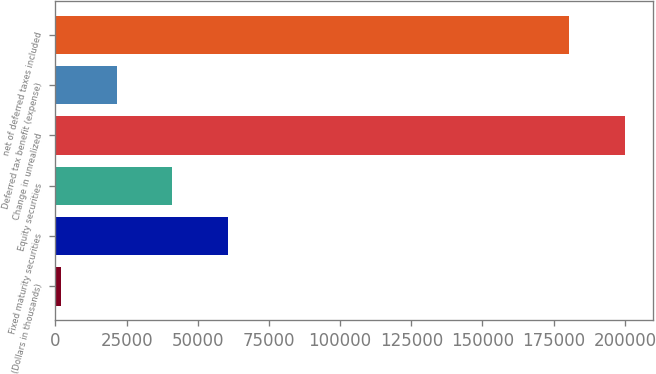Convert chart. <chart><loc_0><loc_0><loc_500><loc_500><bar_chart><fcel>(Dollars in thousands)<fcel>Fixed maturity securities<fcel>Equity securities<fcel>Change in unrealized<fcel>Deferred tax benefit (expense)<fcel>net of deferred taxes included<nl><fcel>2015<fcel>60579.8<fcel>41058.2<fcel>199961<fcel>21536.6<fcel>180439<nl></chart> 